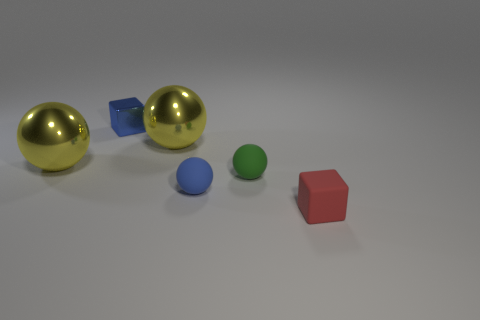There is a rubber block; is its color the same as the tiny sphere on the left side of the green ball?
Your answer should be very brief. No. There is a red matte cube; are there any things behind it?
Your answer should be very brief. Yes. Is the material of the tiny red block the same as the green thing?
Give a very brief answer. Yes. What is the material of the green ball that is the same size as the metal block?
Make the answer very short. Rubber. How many things are tiny matte objects that are to the left of the tiny green rubber thing or yellow shiny things?
Make the answer very short. 3. Are there the same number of yellow things behind the metallic cube and shiny balls?
Give a very brief answer. No. Do the rubber cube and the small shiny cube have the same color?
Keep it short and to the point. No. What is the color of the object that is right of the metal cube and to the left of the small blue rubber sphere?
Offer a terse response. Yellow. What number of spheres are small shiny things or large yellow metal objects?
Ensure brevity in your answer.  2. Is the number of big metallic objects on the right side of the tiny blue sphere less than the number of shiny cylinders?
Keep it short and to the point. No. 